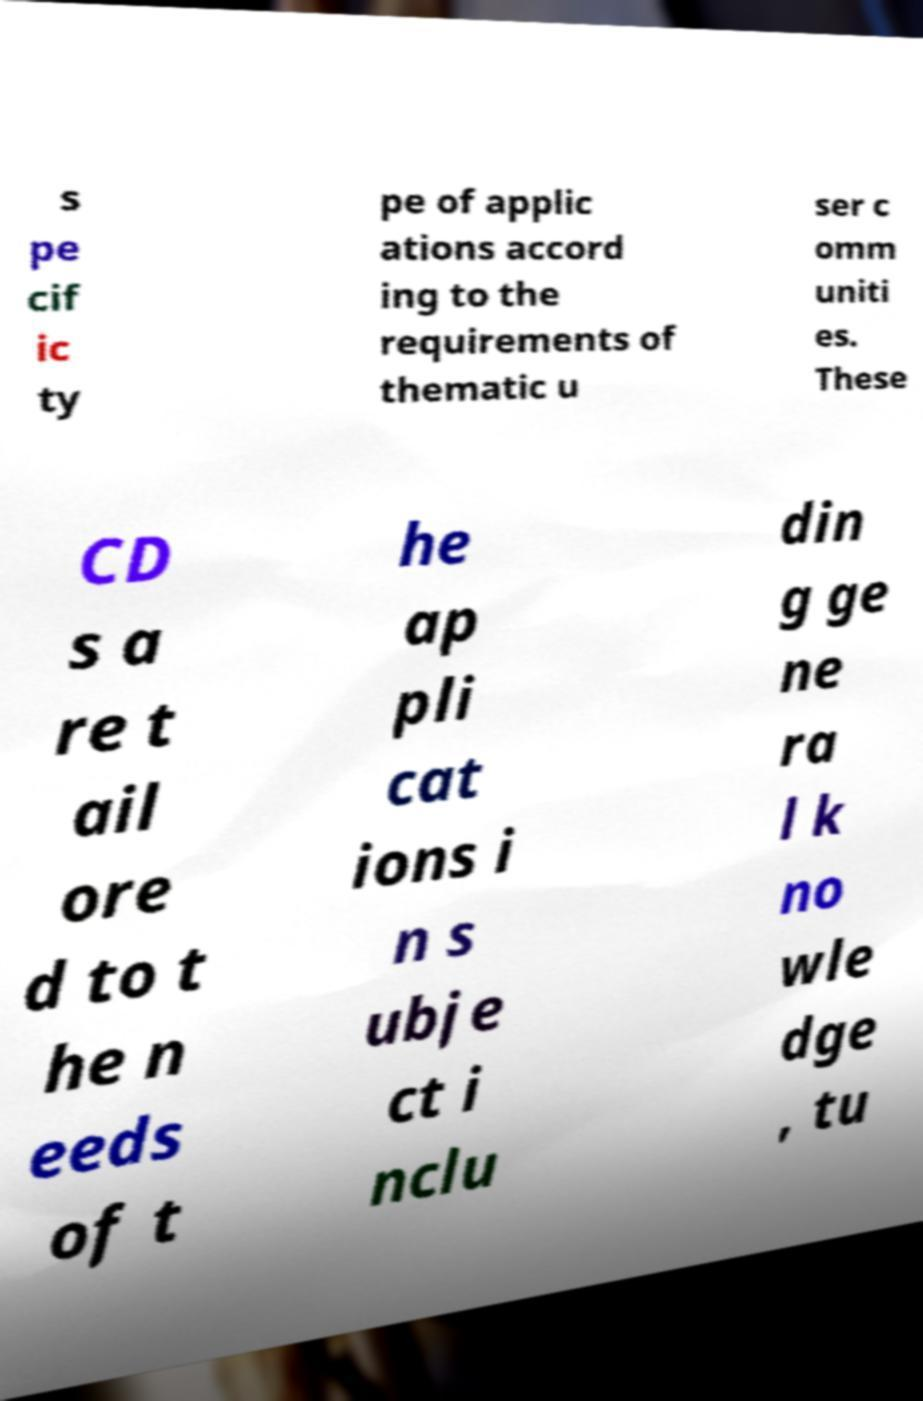Please identify and transcribe the text found in this image. s pe cif ic ty pe of applic ations accord ing to the requirements of thematic u ser c omm uniti es. These CD s a re t ail ore d to t he n eeds of t he ap pli cat ions i n s ubje ct i nclu din g ge ne ra l k no wle dge , tu 